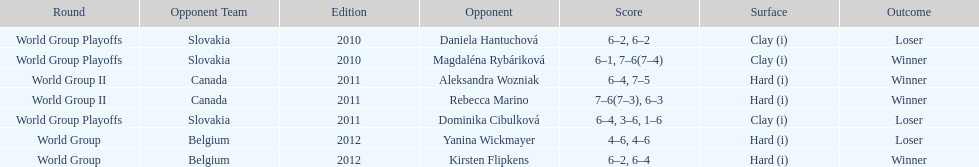Number of games in the match against dominika cibulkova? 3. 